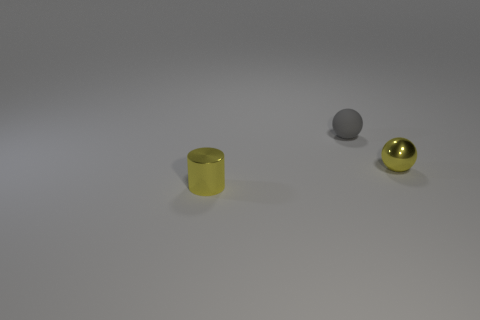Add 3 big purple blocks. How many objects exist? 6 Subtract all spheres. How many objects are left? 1 Add 1 small metal things. How many small metal things are left? 3 Add 3 red metallic cylinders. How many red metallic cylinders exist? 3 Subtract 0 green cylinders. How many objects are left? 3 Subtract all tiny red metal things. Subtract all small metallic things. How many objects are left? 1 